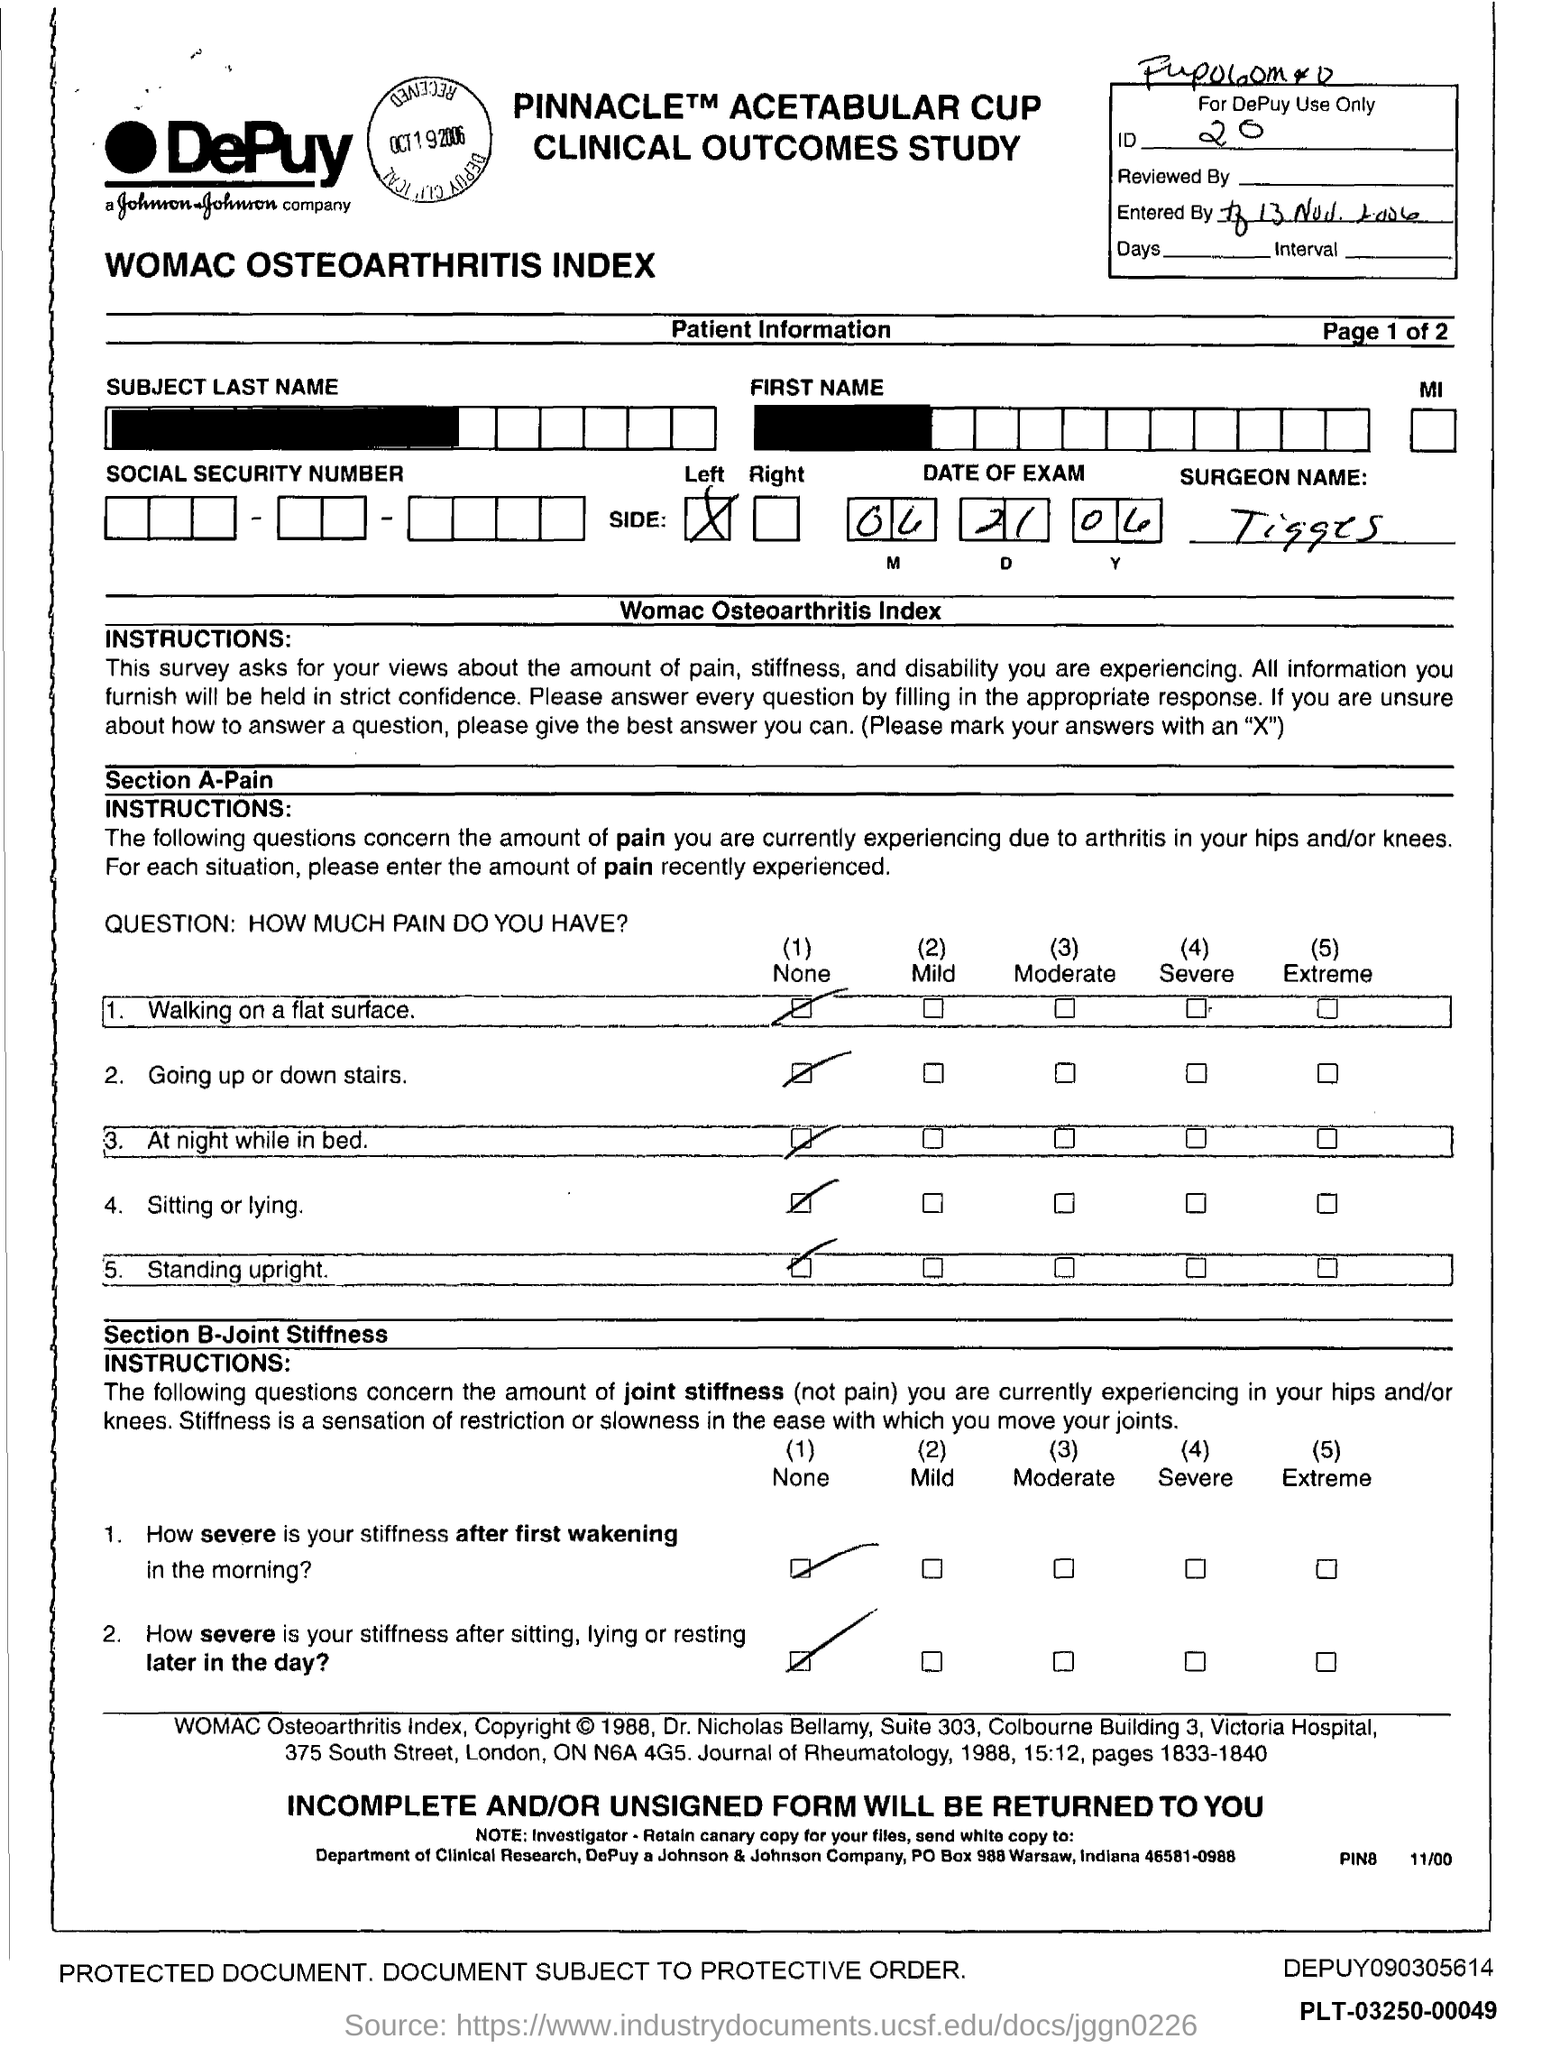Mention a couple of crucial points in this snapshot. The name of the surgeon is Tigges. 